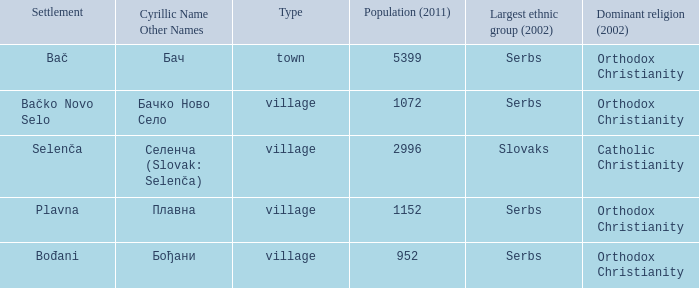What is the second way of writting плавна. Plavna. 